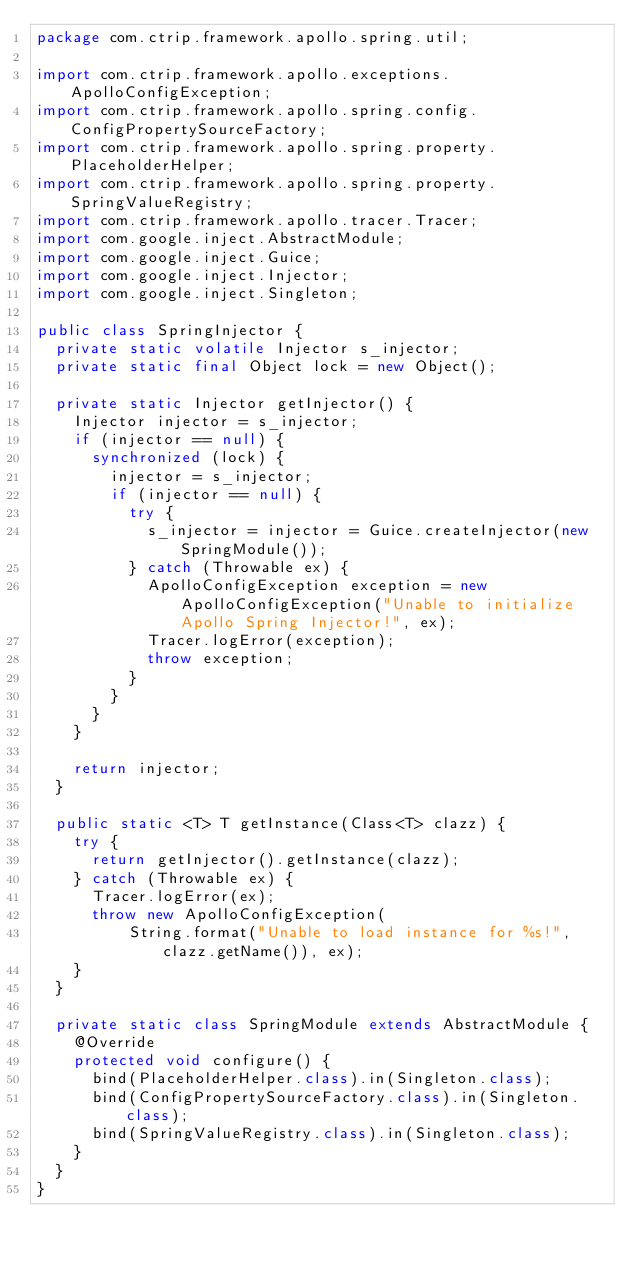<code> <loc_0><loc_0><loc_500><loc_500><_Java_>package com.ctrip.framework.apollo.spring.util;

import com.ctrip.framework.apollo.exceptions.ApolloConfigException;
import com.ctrip.framework.apollo.spring.config.ConfigPropertySourceFactory;
import com.ctrip.framework.apollo.spring.property.PlaceholderHelper;
import com.ctrip.framework.apollo.spring.property.SpringValueRegistry;
import com.ctrip.framework.apollo.tracer.Tracer;
import com.google.inject.AbstractModule;
import com.google.inject.Guice;
import com.google.inject.Injector;
import com.google.inject.Singleton;

public class SpringInjector {
  private static volatile Injector s_injector;
  private static final Object lock = new Object();

  private static Injector getInjector() {
    Injector injector = s_injector;
    if (injector == null) {
      synchronized (lock) {
        injector = s_injector;
        if (injector == null) {
          try {
            s_injector = injector = Guice.createInjector(new SpringModule());
          } catch (Throwable ex) {
            ApolloConfigException exception = new ApolloConfigException("Unable to initialize Apollo Spring Injector!", ex);
            Tracer.logError(exception);
            throw exception;
          }
        }
      }
    }

    return injector;
  }

  public static <T> T getInstance(Class<T> clazz) {
    try {
      return getInjector().getInstance(clazz);
    } catch (Throwable ex) {
      Tracer.logError(ex);
      throw new ApolloConfigException(
          String.format("Unable to load instance for %s!", clazz.getName()), ex);
    }
  }

  private static class SpringModule extends AbstractModule {
    @Override
    protected void configure() {
      bind(PlaceholderHelper.class).in(Singleton.class);
      bind(ConfigPropertySourceFactory.class).in(Singleton.class);
      bind(SpringValueRegistry.class).in(Singleton.class);
    }
  }
}
</code> 